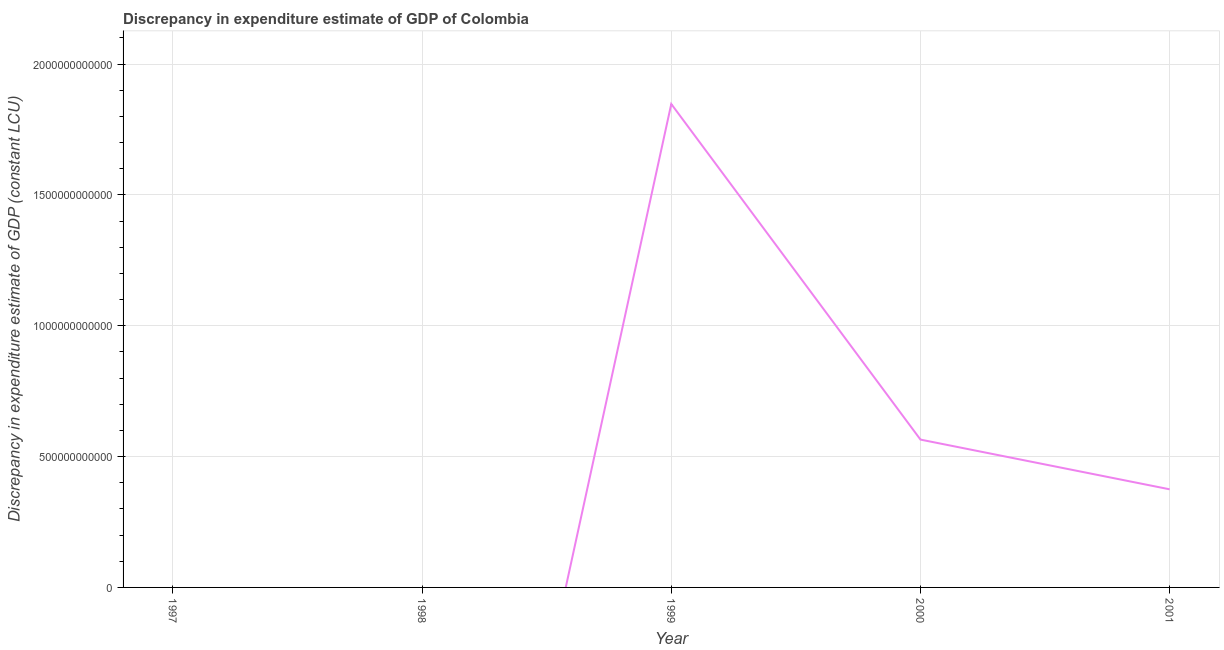Across all years, what is the maximum discrepancy in expenditure estimate of gdp?
Your response must be concise. 1.85e+12. Across all years, what is the minimum discrepancy in expenditure estimate of gdp?
Keep it short and to the point. 0. In which year was the discrepancy in expenditure estimate of gdp maximum?
Ensure brevity in your answer.  1999. What is the sum of the discrepancy in expenditure estimate of gdp?
Provide a succinct answer. 2.79e+12. What is the difference between the discrepancy in expenditure estimate of gdp in 1999 and 2000?
Ensure brevity in your answer.  1.28e+12. What is the average discrepancy in expenditure estimate of gdp per year?
Offer a very short reply. 5.58e+11. What is the median discrepancy in expenditure estimate of gdp?
Provide a succinct answer. 3.75e+11. In how many years, is the discrepancy in expenditure estimate of gdp greater than 300000000000 LCU?
Provide a short and direct response. 3. What is the ratio of the discrepancy in expenditure estimate of gdp in 1999 to that in 2000?
Your answer should be very brief. 3.27. What is the difference between the highest and the second highest discrepancy in expenditure estimate of gdp?
Provide a short and direct response. 1.28e+12. What is the difference between the highest and the lowest discrepancy in expenditure estimate of gdp?
Your answer should be very brief. 1.85e+12. What is the difference between two consecutive major ticks on the Y-axis?
Give a very brief answer. 5.00e+11. Are the values on the major ticks of Y-axis written in scientific E-notation?
Ensure brevity in your answer.  No. Does the graph contain any zero values?
Offer a terse response. Yes. What is the title of the graph?
Make the answer very short. Discrepancy in expenditure estimate of GDP of Colombia. What is the label or title of the Y-axis?
Ensure brevity in your answer.  Discrepancy in expenditure estimate of GDP (constant LCU). What is the Discrepancy in expenditure estimate of GDP (constant LCU) of 1997?
Offer a terse response. 0. What is the Discrepancy in expenditure estimate of GDP (constant LCU) of 1999?
Offer a very short reply. 1.85e+12. What is the Discrepancy in expenditure estimate of GDP (constant LCU) of 2000?
Your answer should be very brief. 5.65e+11. What is the Discrepancy in expenditure estimate of GDP (constant LCU) in 2001?
Offer a terse response. 3.75e+11. What is the difference between the Discrepancy in expenditure estimate of GDP (constant LCU) in 1999 and 2000?
Provide a succinct answer. 1.28e+12. What is the difference between the Discrepancy in expenditure estimate of GDP (constant LCU) in 1999 and 2001?
Provide a short and direct response. 1.47e+12. What is the difference between the Discrepancy in expenditure estimate of GDP (constant LCU) in 2000 and 2001?
Your response must be concise. 1.90e+11. What is the ratio of the Discrepancy in expenditure estimate of GDP (constant LCU) in 1999 to that in 2000?
Make the answer very short. 3.27. What is the ratio of the Discrepancy in expenditure estimate of GDP (constant LCU) in 1999 to that in 2001?
Offer a terse response. 4.93. What is the ratio of the Discrepancy in expenditure estimate of GDP (constant LCU) in 2000 to that in 2001?
Your response must be concise. 1.51. 